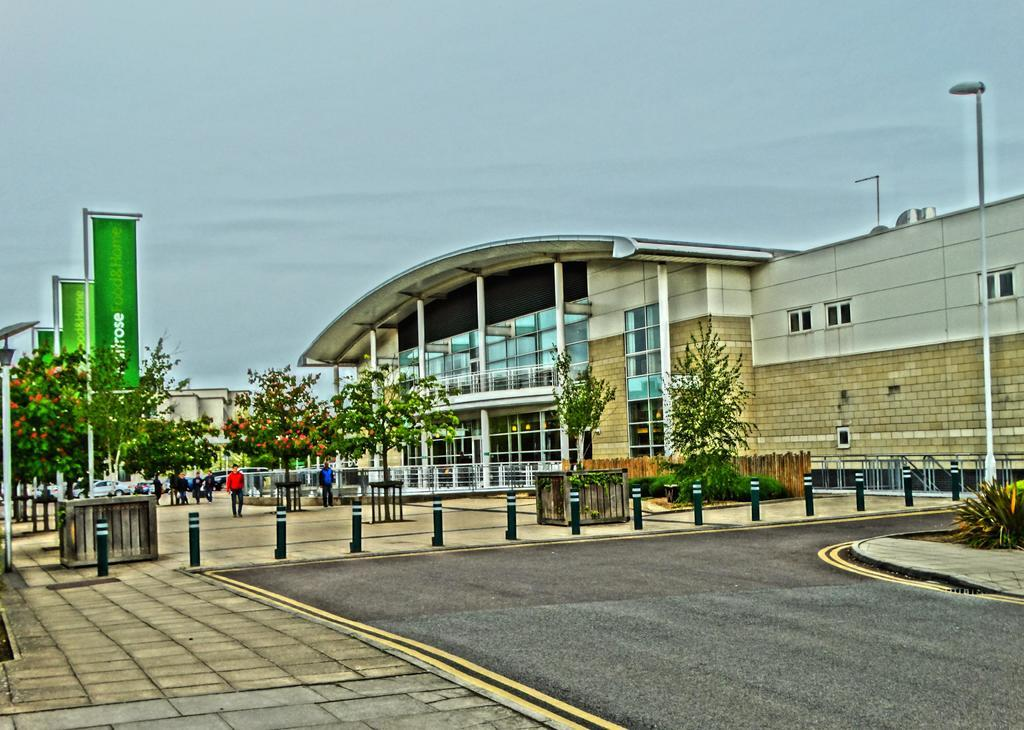How many people are in the group visible in the image? There is a group of people standing in the image, but the exact number cannot be determined from the provided facts. What types of vehicles can be seen in the image? There are vehicles in the image, but the specific types cannot be determined from the provided facts. What are the poles used for in the image? The purpose of the poles in the image cannot be determined from the provided facts. What is the purpose of the lights in the image? The purpose of the lights in the image cannot be determined from the provided facts. What are the boards used for in the image? The purpose of the boards in the image cannot be determined from the provided facts. What types of plants are in the image? There are plants in the image, but the specific types cannot be determined from the provided facts. What types of trees are in the image? There are trees in the image, but the specific types cannot be determined from the provided facts. What is the building used for in the image? The purpose of the building in the image cannot be determined from the provided facts. What is visible in the background of the image? The sky is visible in the background of the image. Can you tell me how many basketballs are on the route in the image? There is no mention of basketballs or a route in the image, so this question cannot be answered definitively. 